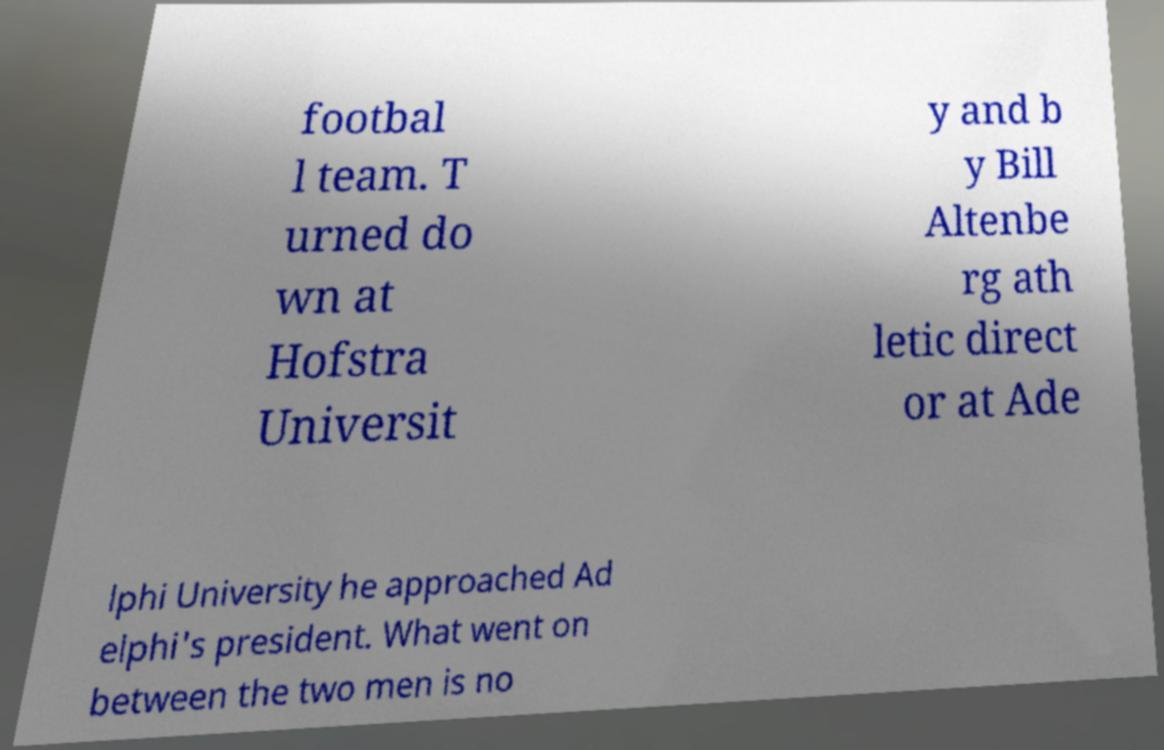For documentation purposes, I need the text within this image transcribed. Could you provide that? footbal l team. T urned do wn at Hofstra Universit y and b y Bill Altenbe rg ath letic direct or at Ade lphi University he approached Ad elphi's president. What went on between the two men is no 